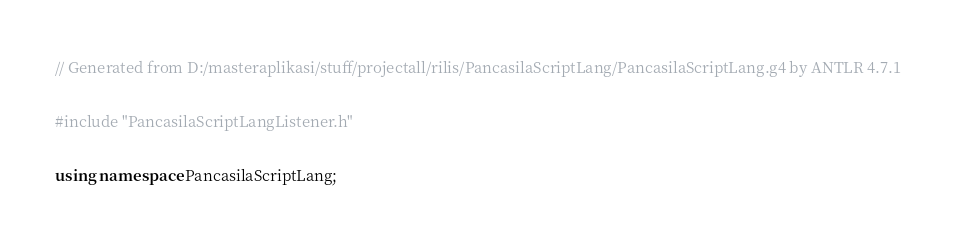Convert code to text. <code><loc_0><loc_0><loc_500><loc_500><_C++_>
// Generated from D:/masteraplikasi/stuff/projectall/rilis/PancasilaScriptLang/PancasilaScriptLang.g4 by ANTLR 4.7.1


#include "PancasilaScriptLangListener.h"


using namespace PancasilaScriptLang;

</code> 